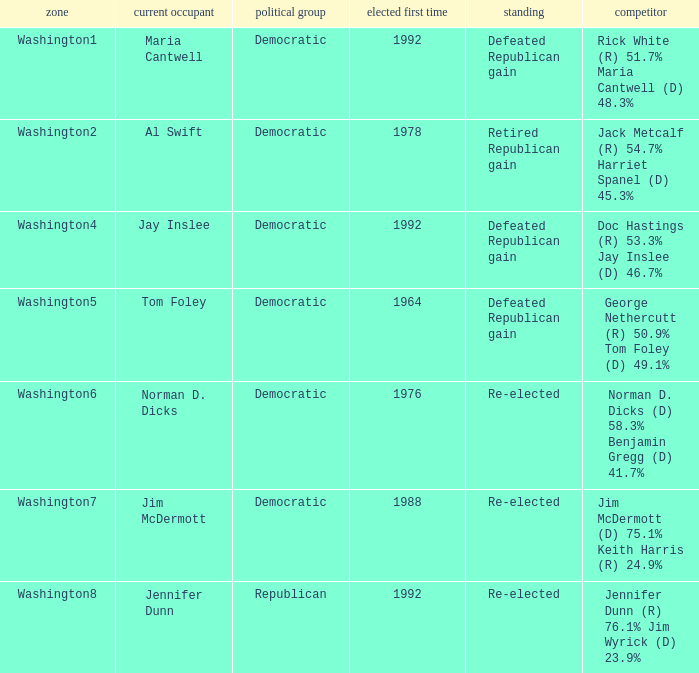7%? Defeated Republican gain. 